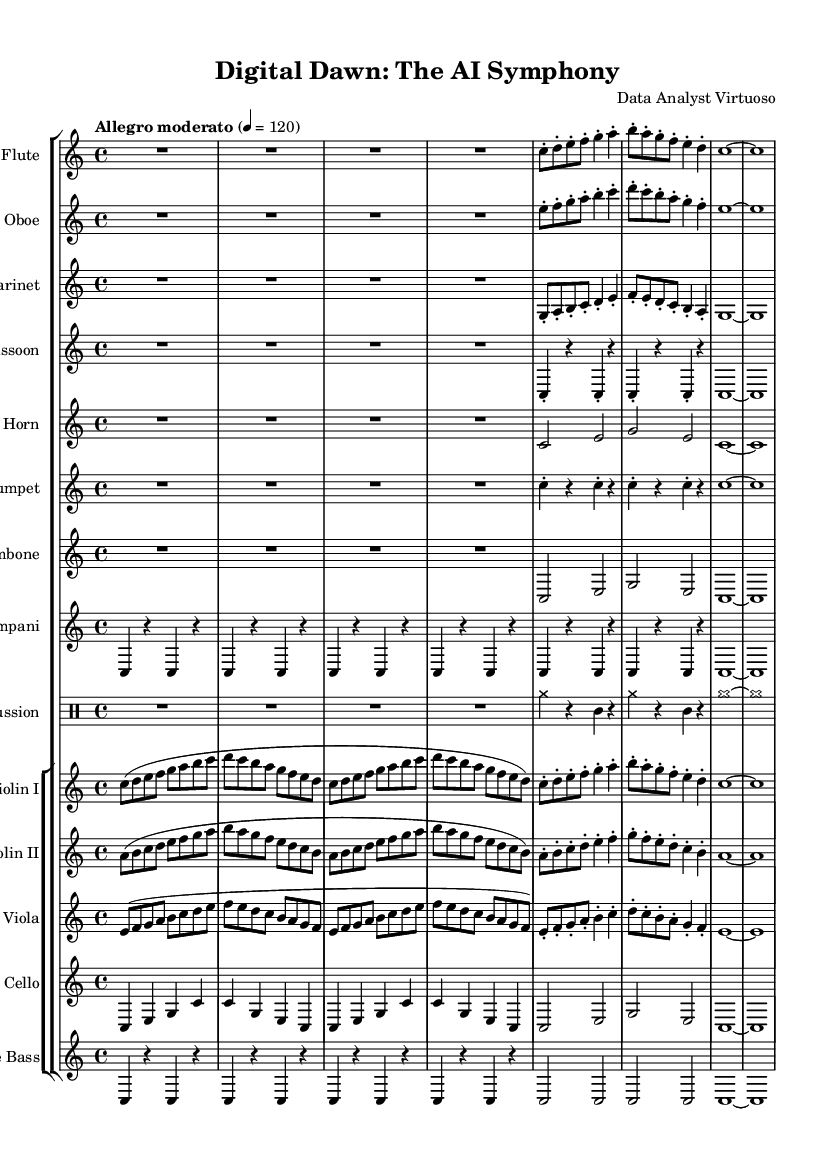What is the key signature of this music? The key signature is C major, which has no sharps or flats.
Answer: C major What is the time signature of this piece? The time signature appears prominently at the beginning of the score as 4/4, indicating four beats per measure.
Answer: 4/4 What is the tempo marking given for this symphony? The tempo marking noted in the top section of the score is "Allegro moderato," which suggests a moderately fast pace.
Answer: Allegro moderato How many measures are in the flute part? The flute part consists of 8 measures as identified by the vertical lines that denote measure boundaries in the score.
Answer: 8 Which instrument has the lowest pitch range in this symphony? Analyzing the score, the double bass generally plays the lowest pitches, as evidenced by its written part being in the bass clef and often positioned lower than other instruments.
Answer: Double Bass What is the dominant motive in the violins? The violins exhibit a repetitive ascending scale pattern, particularly evident in the first section of their part, signifying their role in developing the main thematic material.
Answer: Ascending scale How does the percussion contribute to the overall sound texture? The percussion section includes cymbals and triangle, which add color and accentuate rhythmic elements, contributing significantly to the piece's dynamic contrast and auditory depth.
Answer: Color and rhythm 